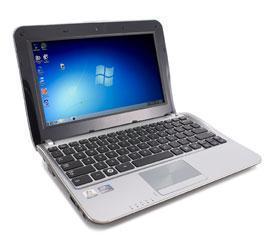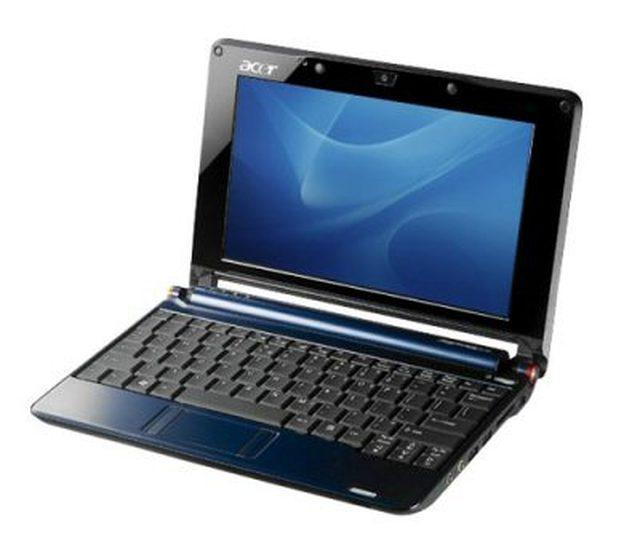The first image is the image on the left, the second image is the image on the right. Given the left and right images, does the statement "The laptop on the left image has a silver body around the keyboard." hold true? Answer yes or no. Yes. 